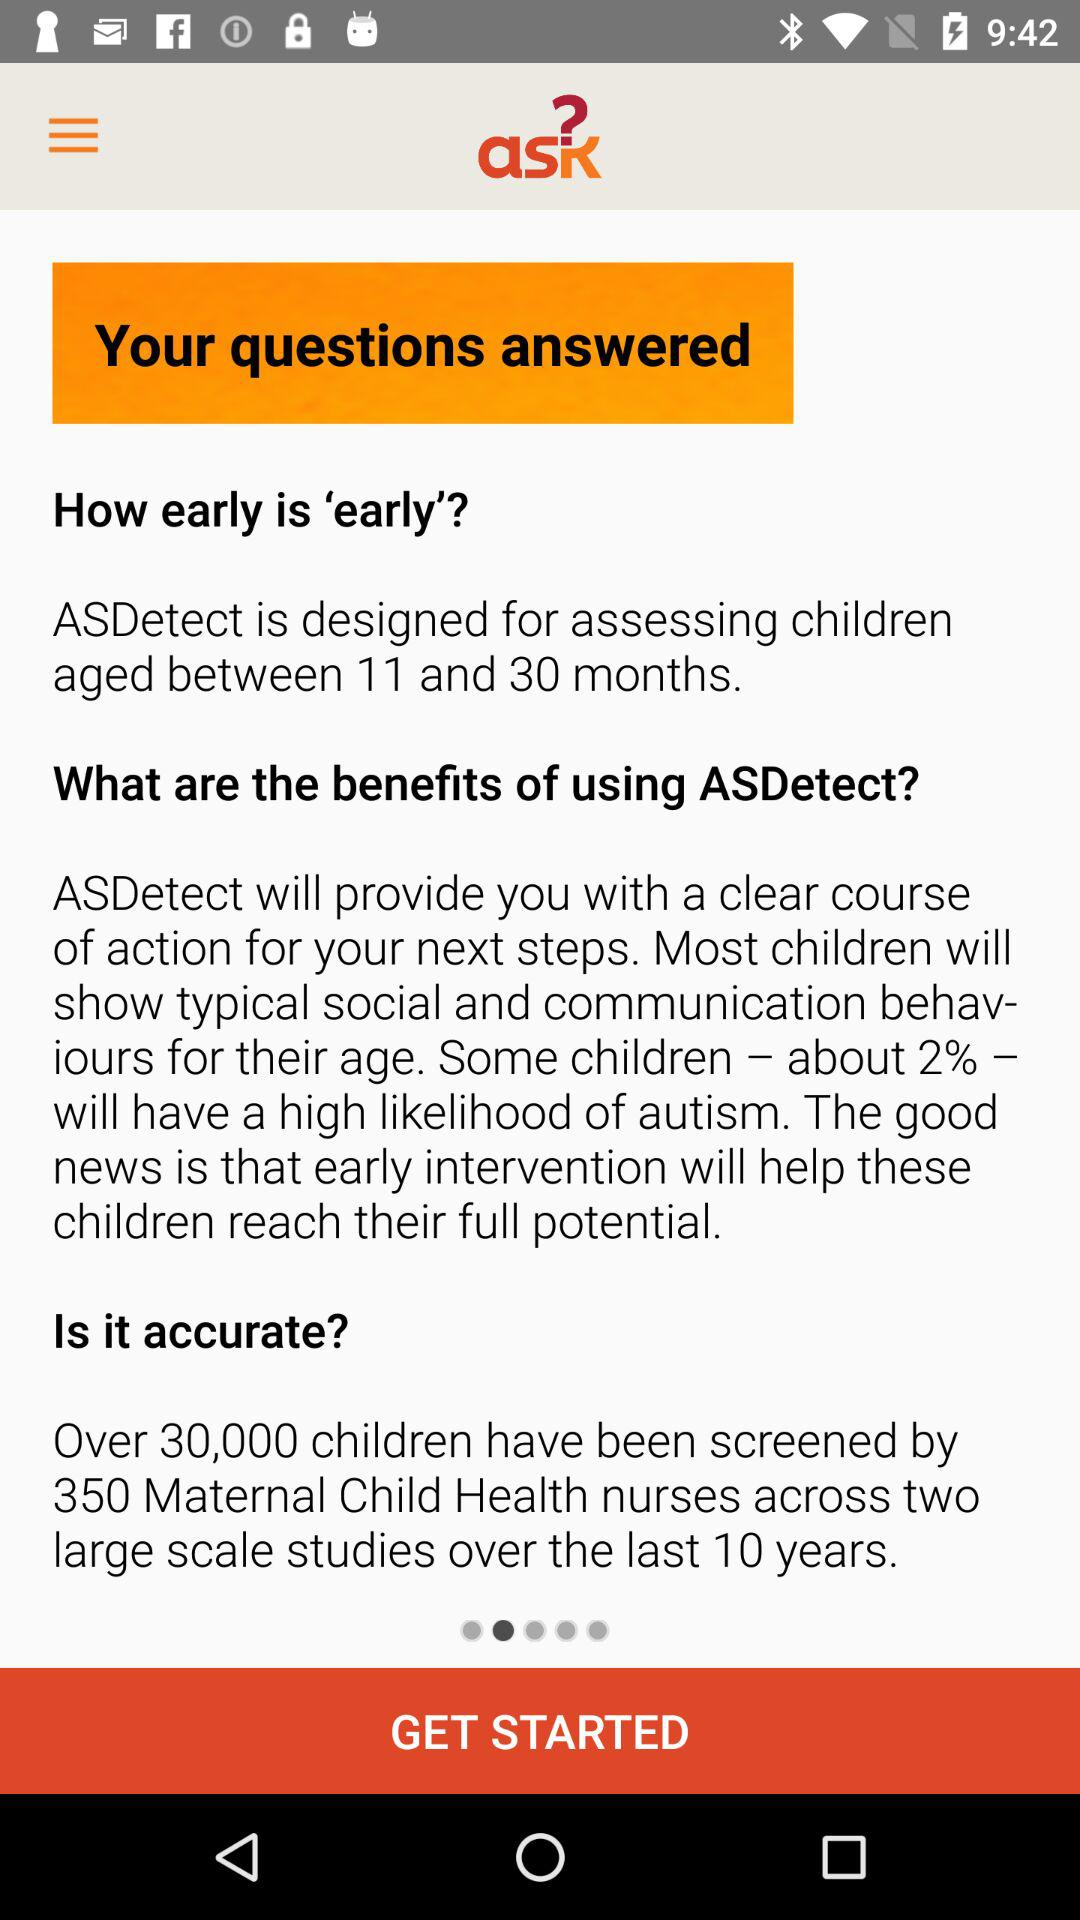What is the application name? The application name is "ask". 